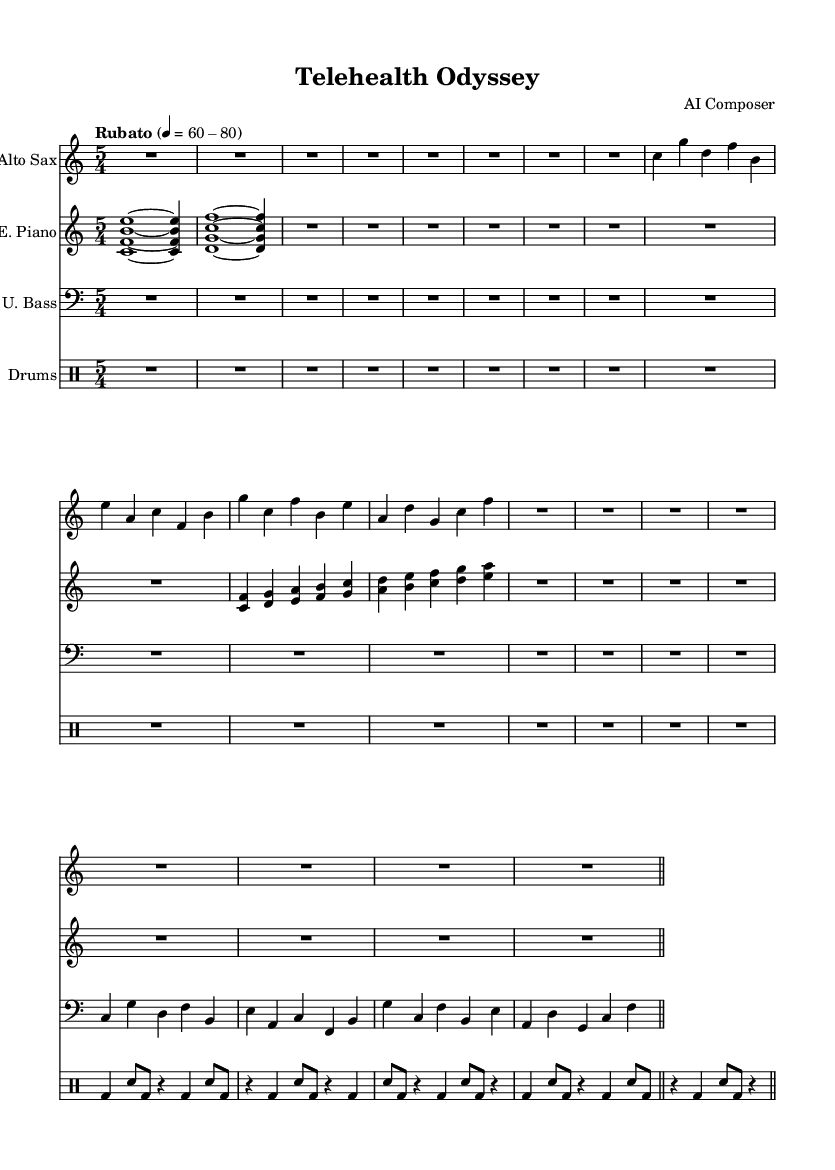What is the time signature of this music? The time signature is located at the beginning and is indicated as 5/4, meaning there are five beats in each measure and the quarter note gets one beat.
Answer: 5/4 What is the tempo marking for this piece? The tempo is indicated in the header, stating "Rubato" with a range of 60-80 beats per minute, suggesting a flexible tempo.
Answer: Rubato 60-80 How many instruments are included in this score? By counting the distinct staffs visible in the score, it is clear there are four instruments: Alto Sax, Electric Piano, Upright Bass, and Drums.
Answer: Four Which instrument has the lowest pitch range in this piece? The Upright Bass is notated in the bass clef, which typically covers lower pitches compared to the other instruments in this score.
Answer: Upright Bass What type of jazz piece is this composition? The composition is described as "Avant-garde jazz," which showcases innovative and unconventional approaches, aligning with the theme of telemedicine and remote care evolution.
Answer: Avant-garde jazz Which instrumental part has the most rhythmic variation? The Drums part includes an intricate pattern of bass drum and snare hits, showcasing diverse rhythms compared to the melodic lines of the other instruments.
Answer: Drums What does the rest symbol in the alto sax part indicate? The rest symbol denotes that the saxophonist should remain silent for that duration, allowing space for the music's flow and dynamics.
Answer: Silence 